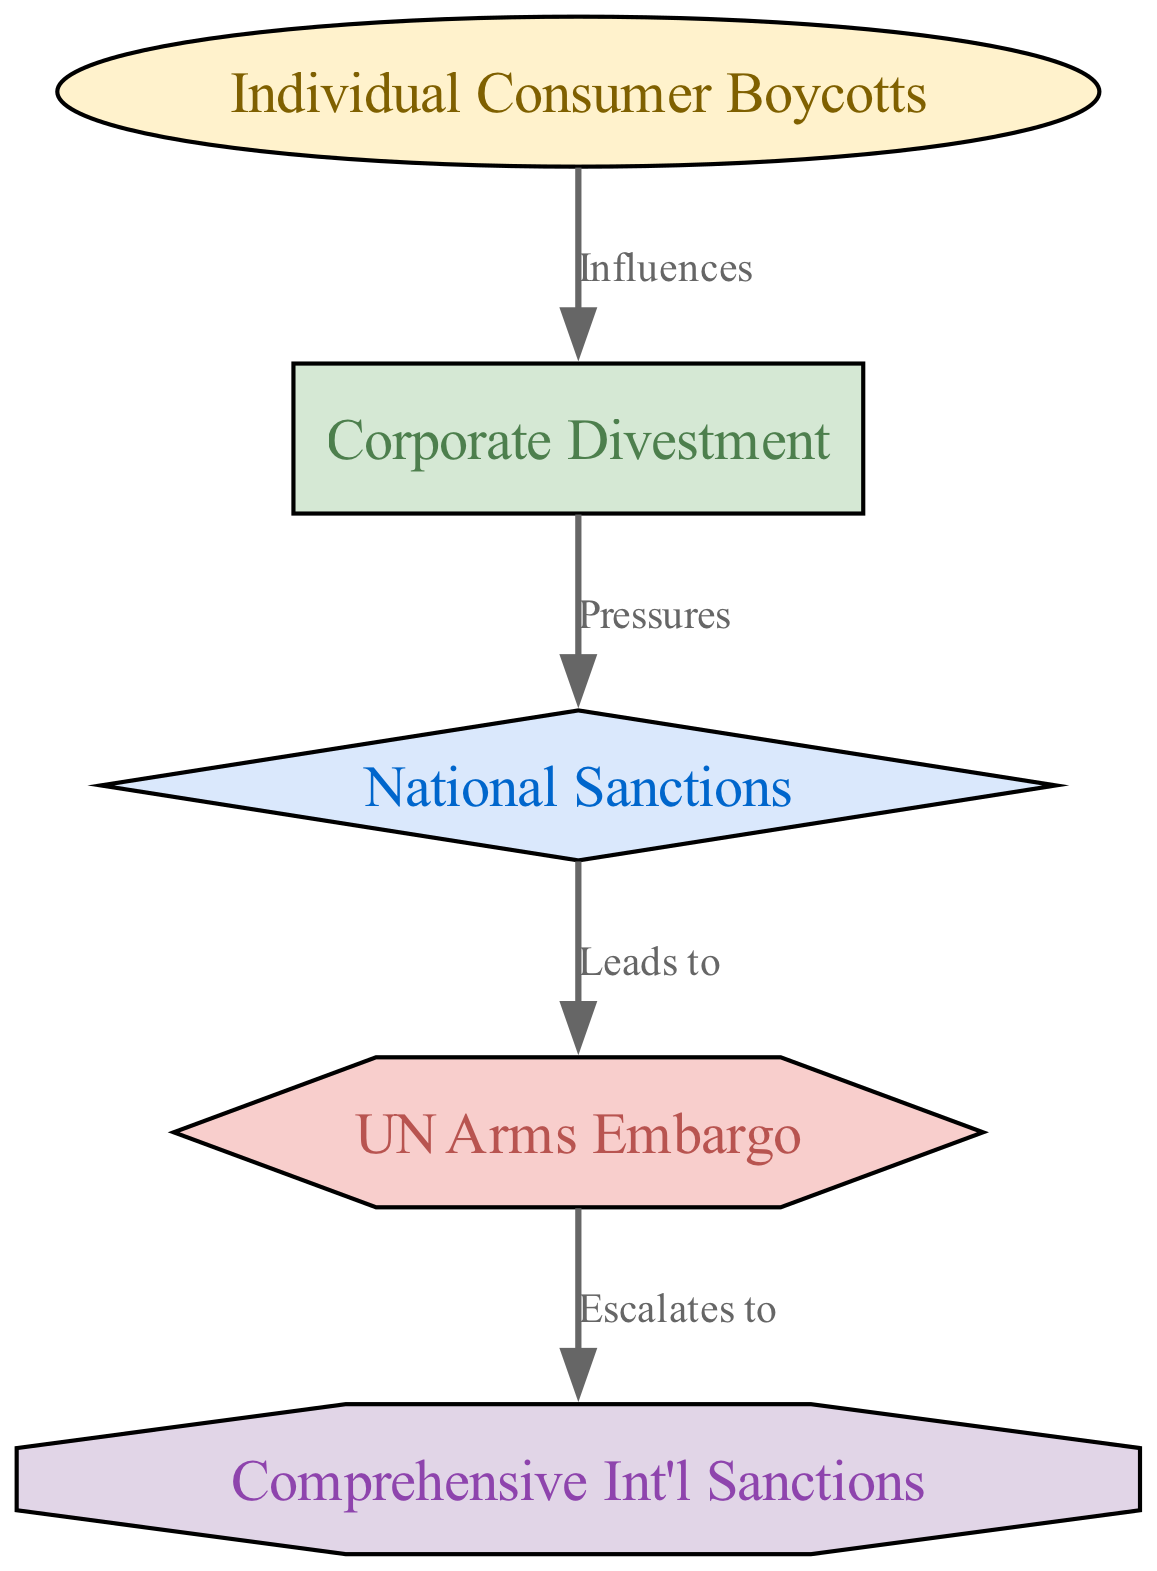What is the first step in the progression of sanctions against South Africa? The diagram indicates that the first step is "Individual Consumer Boycotts," which is denoted as level 1. This is the starting element in the flow of sanctions.
Answer: Individual Consumer Boycotts How many nodes are present in the diagram? By counting the distinct nodes listed in the data: "Individual Consumer Boycotts," "Corporate Divestment," "National Sanctions," "UN Arms Embargo," and "Comprehensive Int'l Sanctions," we find there are five nodes in total.
Answer: 5 What action is influenced by "Individual Consumer Boycotts"? The diagram specifies that "Corporate Divestment" is influenced by "Individual Consumer Boycotts," indicating a directional relationship where consumer actions lead to corporate responses.
Answer: Corporate Divestment Which node leads to "UN Arms Embargo"? From the diagram, "National Sanctions" leads to "UN Arms Embargo," showing that national-level decisions in sanctions can escalate to actions coordinated by the United Nations.
Answer: National Sanctions What is the highest level of sanctions depicted in the diagram? The highest level indicated in the diagram is "Comprehensive Int'l Sanctions," which is assigned as level 5, illustrating the most severe form of imposed sanctions.
Answer: Comprehensive Int'l Sanctions What type of relationship is there between "Corporate Divestment" and "National Sanctions"? The diagram specifies that "Corporate Divestment" exerts "Pressures" on "National Sanctions," indicating that corporate actions can influence governmental sanctions policies.
Answer: Pressures If "UN Arms Embargo" escalates to what other node? According to the diagram, "UN Arms Embargo" escalates to "Comprehensive Int'l Sanctions," suggesting that actions taken by the UN can lead to broader international sanctions.
Answer: Comprehensive Int'l Sanctions In total, how many edges are represented in the diagram? By examining the relationships listed in the diagram, there are four edges connecting the nodes, which represent the directional ties between different levels of sanctions.
Answer: 4 What level is "Corporate Divestment" categorized under? The diagram categorizes "Corporate Divestment" under level 2, which indicates it is the second step in the progression of sanctions after individual boycotts.
Answer: 2 